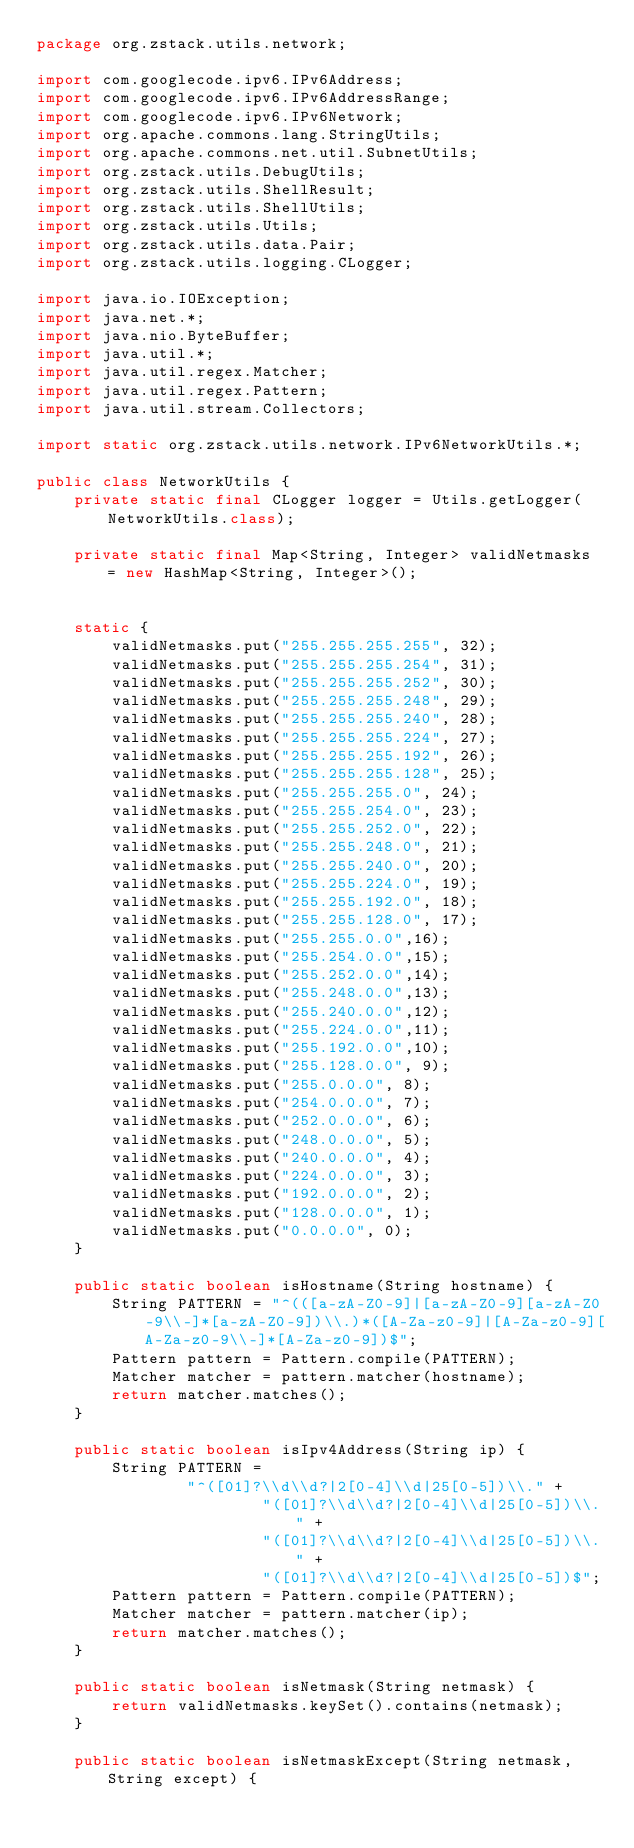Convert code to text. <code><loc_0><loc_0><loc_500><loc_500><_Java_>package org.zstack.utils.network;

import com.googlecode.ipv6.IPv6Address;
import com.googlecode.ipv6.IPv6AddressRange;
import com.googlecode.ipv6.IPv6Network;
import org.apache.commons.lang.StringUtils;
import org.apache.commons.net.util.SubnetUtils;
import org.zstack.utils.DebugUtils;
import org.zstack.utils.ShellResult;
import org.zstack.utils.ShellUtils;
import org.zstack.utils.Utils;
import org.zstack.utils.data.Pair;
import org.zstack.utils.logging.CLogger;

import java.io.IOException;
import java.net.*;
import java.nio.ByteBuffer;
import java.util.*;
import java.util.regex.Matcher;
import java.util.regex.Pattern;
import java.util.stream.Collectors;

import static org.zstack.utils.network.IPv6NetworkUtils.*;

public class NetworkUtils {
    private static final CLogger logger = Utils.getLogger(NetworkUtils.class);

    private static final Map<String, Integer> validNetmasks = new HashMap<String, Integer>();


    static {
        validNetmasks.put("255.255.255.255", 32);
        validNetmasks.put("255.255.255.254", 31);
        validNetmasks.put("255.255.255.252", 30);
        validNetmasks.put("255.255.255.248", 29);
        validNetmasks.put("255.255.255.240", 28);
        validNetmasks.put("255.255.255.224", 27);
        validNetmasks.put("255.255.255.192", 26);
        validNetmasks.put("255.255.255.128", 25);
        validNetmasks.put("255.255.255.0", 24);
        validNetmasks.put("255.255.254.0", 23);
        validNetmasks.put("255.255.252.0", 22);
        validNetmasks.put("255.255.248.0", 21);
        validNetmasks.put("255.255.240.0", 20);
        validNetmasks.put("255.255.224.0", 19);
        validNetmasks.put("255.255.192.0", 18);
        validNetmasks.put("255.255.128.0", 17);
        validNetmasks.put("255.255.0.0",16);
        validNetmasks.put("255.254.0.0",15);
        validNetmasks.put("255.252.0.0",14);
        validNetmasks.put("255.248.0.0",13);
        validNetmasks.put("255.240.0.0",12);
        validNetmasks.put("255.224.0.0",11);
        validNetmasks.put("255.192.0.0",10);
        validNetmasks.put("255.128.0.0", 9);
        validNetmasks.put("255.0.0.0", 8);
        validNetmasks.put("254.0.0.0", 7);
        validNetmasks.put("252.0.0.0", 6);
        validNetmasks.put("248.0.0.0", 5);
        validNetmasks.put("240.0.0.0", 4);
        validNetmasks.put("224.0.0.0", 3);
        validNetmasks.put("192.0.0.0", 2);
        validNetmasks.put("128.0.0.0", 1);
        validNetmasks.put("0.0.0.0", 0);
    }

    public static boolean isHostname(String hostname) {
        String PATTERN = "^(([a-zA-Z0-9]|[a-zA-Z0-9][a-zA-Z0-9\\-]*[a-zA-Z0-9])\\.)*([A-Za-z0-9]|[A-Za-z0-9][A-Za-z0-9\\-]*[A-Za-z0-9])$";
        Pattern pattern = Pattern.compile(PATTERN);
        Matcher matcher = pattern.matcher(hostname);
        return matcher.matches();
    }

    public static boolean isIpv4Address(String ip) {
        String PATTERN =
                "^([01]?\\d\\d?|2[0-4]\\d|25[0-5])\\." +
                        "([01]?\\d\\d?|2[0-4]\\d|25[0-5])\\." +
                        "([01]?\\d\\d?|2[0-4]\\d|25[0-5])\\." +
                        "([01]?\\d\\d?|2[0-4]\\d|25[0-5])$";
        Pattern pattern = Pattern.compile(PATTERN);
        Matcher matcher = pattern.matcher(ip);
        return matcher.matches();
    }

    public static boolean isNetmask(String netmask) {
        return validNetmasks.keySet().contains(netmask);
    }

    public static boolean isNetmaskExcept(String netmask, String except) {</code> 